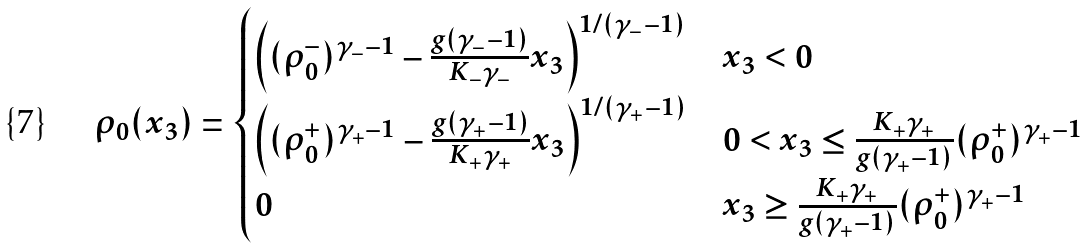<formula> <loc_0><loc_0><loc_500><loc_500>\rho _ { 0 } ( x _ { 3 } ) = \begin{cases} \left ( ( \rho _ { 0 } ^ { - } ) ^ { \gamma _ { - } - 1 } - \frac { g ( \gamma _ { - } - 1 ) } { K _ { - } \gamma _ { - } } x _ { 3 } \right ) ^ { 1 / ( \gamma _ { - } - 1 ) } & x _ { 3 } < 0 \\ \left ( ( \rho _ { 0 } ^ { + } ) ^ { \gamma _ { + } - 1 } - \frac { g ( \gamma _ { + } - 1 ) } { K _ { + } \gamma _ { + } } x _ { 3 } \right ) ^ { 1 / ( \gamma _ { + } - 1 ) } & 0 < x _ { 3 } \leq \frac { K _ { + } \gamma _ { + } } { g ( \gamma _ { + } - 1 ) } ( \rho _ { 0 } ^ { + } ) ^ { \gamma _ { + } - 1 } \\ 0 & x _ { 3 } \geq \frac { K _ { + } \gamma _ { + } } { g ( \gamma _ { + } - 1 ) } ( \rho _ { 0 } ^ { + } ) ^ { \gamma _ { + } - 1 } \end{cases}</formula> 